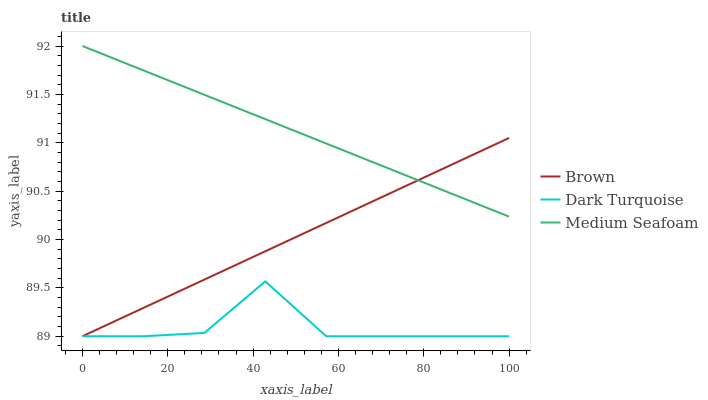Does Dark Turquoise have the minimum area under the curve?
Answer yes or no. Yes. Does Medium Seafoam have the maximum area under the curve?
Answer yes or no. Yes. Does Medium Seafoam have the minimum area under the curve?
Answer yes or no. No. Does Dark Turquoise have the maximum area under the curve?
Answer yes or no. No. Is Brown the smoothest?
Answer yes or no. Yes. Is Dark Turquoise the roughest?
Answer yes or no. Yes. Is Medium Seafoam the smoothest?
Answer yes or no. No. Is Medium Seafoam the roughest?
Answer yes or no. No. Does Brown have the lowest value?
Answer yes or no. Yes. Does Medium Seafoam have the lowest value?
Answer yes or no. No. Does Medium Seafoam have the highest value?
Answer yes or no. Yes. Does Dark Turquoise have the highest value?
Answer yes or no. No. Is Dark Turquoise less than Medium Seafoam?
Answer yes or no. Yes. Is Medium Seafoam greater than Dark Turquoise?
Answer yes or no. Yes. Does Brown intersect Dark Turquoise?
Answer yes or no. Yes. Is Brown less than Dark Turquoise?
Answer yes or no. No. Is Brown greater than Dark Turquoise?
Answer yes or no. No. Does Dark Turquoise intersect Medium Seafoam?
Answer yes or no. No. 